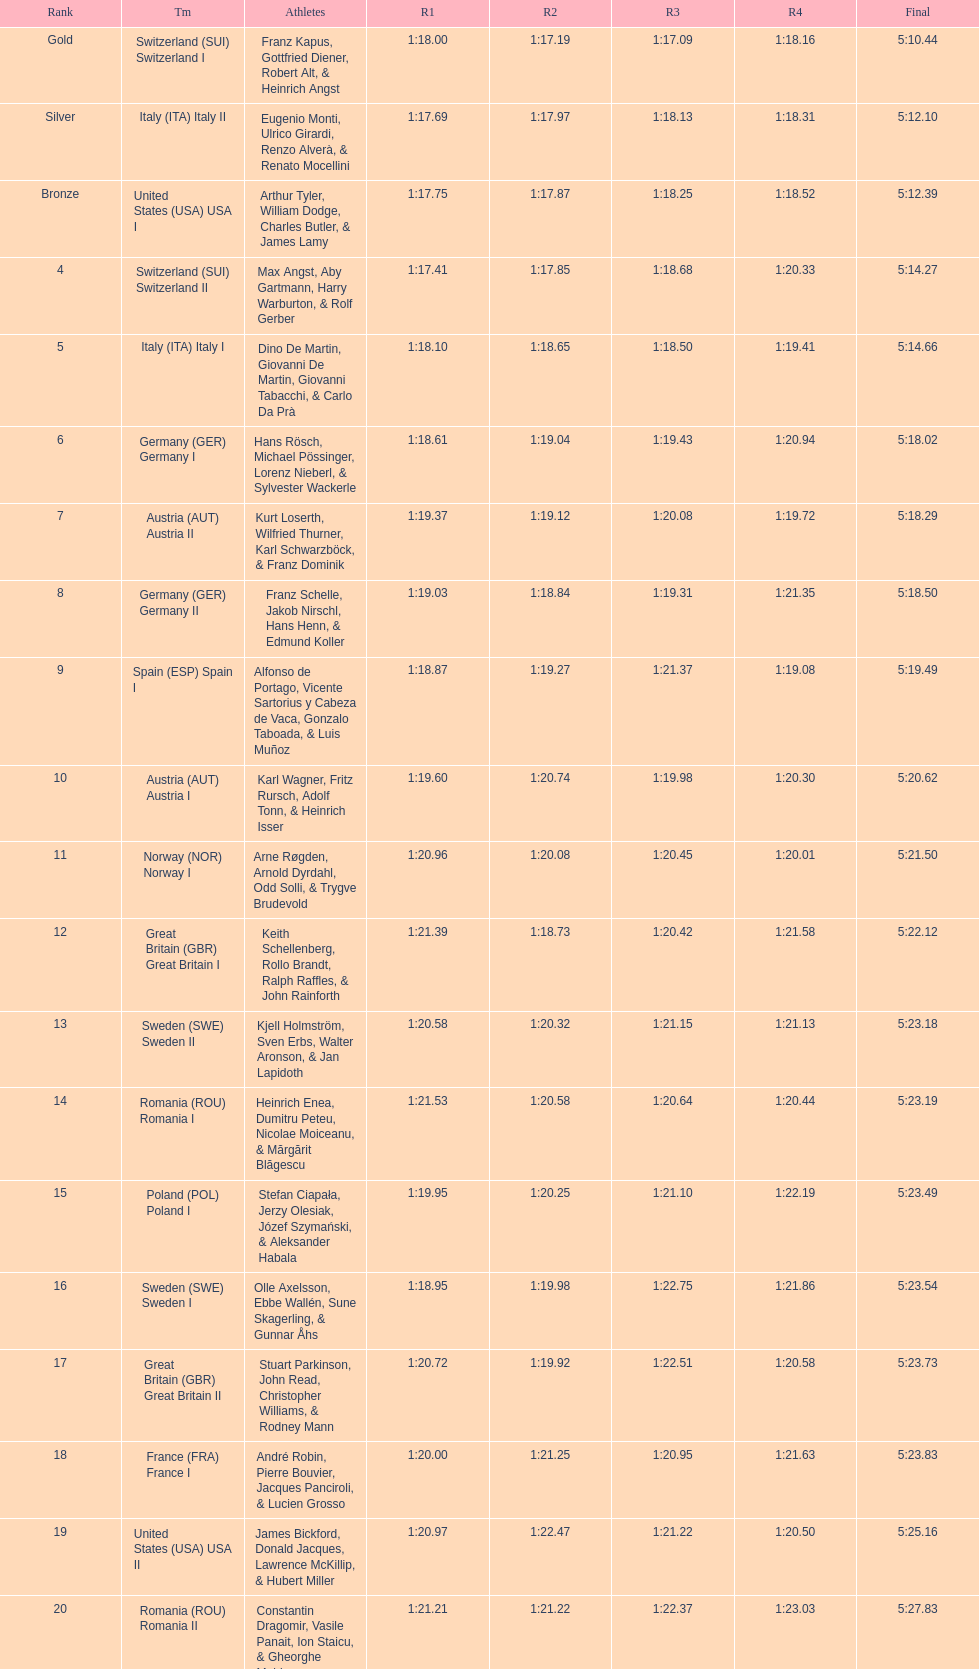What team comes after italy (ita) italy i? Germany I. 